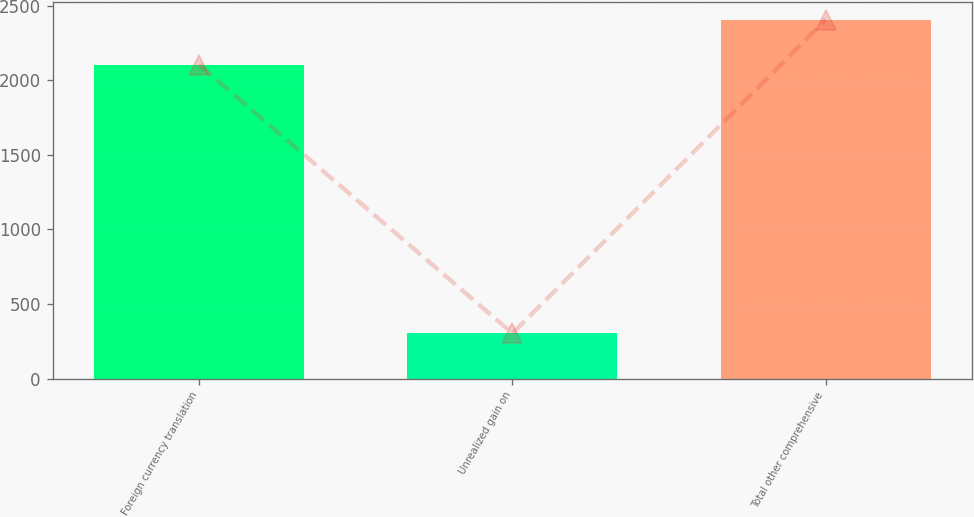Convert chart. <chart><loc_0><loc_0><loc_500><loc_500><bar_chart><fcel>Foreign currency translation<fcel>Unrealized gain on<fcel>Total other comprehensive<nl><fcel>2103<fcel>303<fcel>2406<nl></chart> 